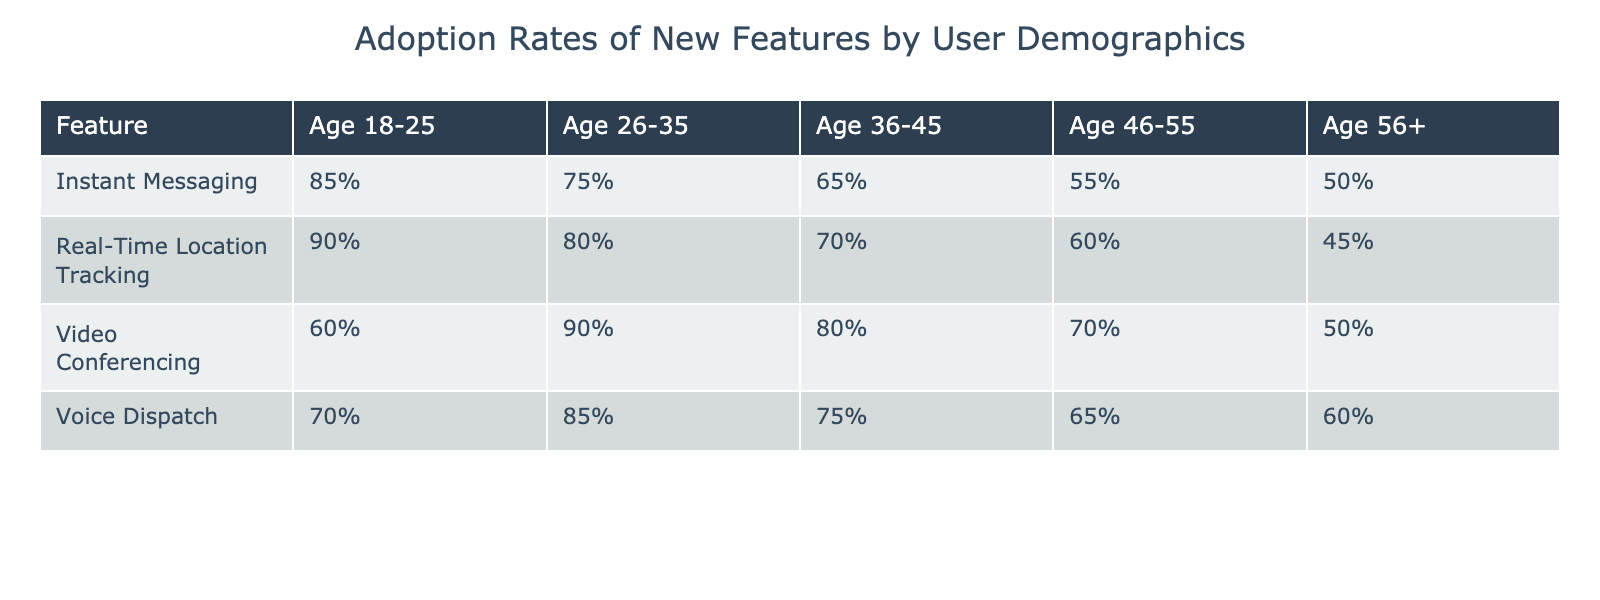What is the adoption rate of Instant Messaging among users aged 46-55 in Q1 2023? The table shows that the adoption rate for Instant Messaging among users aged 46-55 is 55% in Q1 2023.
Answer: 55% Which age group had the highest adoption rate for Real-Time Location Tracking in Q2 2023? By looking at the table, the age group 18-25 has the highest adoption rate for Real-Time Location Tracking with 90% in Q2 2023.
Answer: Age 18-25 What is the adoption rate gap between Voice Dispatch for the age group 26-35 and age group 56+ in Q3 2023? The adoption rate for age group 26-35 is 85% and for age group 56+ is 60%. The gap is calculated as 85% - 60% = 25%.
Answer: 25% Is the adoption rate of Video Conferencing for age group 36-45 higher than that for age group 56+ in Q4 2023? According to the table, the adoption rate for age group 36-45 is 80% while for age group 56+ it is 50%. Therefore, it is true that 80% is greater than 50%.
Answer: Yes What is the average adoption rate for Instant Messaging across all age groups in Q1 2023? The adoption rates for Instant Messaging in Q1 2023 are 85%, 75%, 65%, 55%, and 50% for each age group, respectively. The average is calculated as (85 + 75 + 65 + 55 + 50) / 5 = 66%.
Answer: 66% 